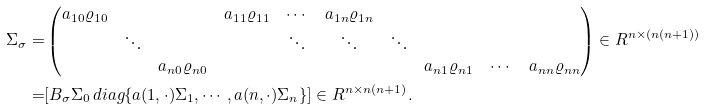<formula> <loc_0><loc_0><loc_500><loc_500>\Sigma _ { \sigma } = & \begin{pmatrix} a _ { 1 0 } \varrho _ { 1 0 } & & & a _ { 1 1 } \varrho _ { 1 1 } & \cdots & a _ { 1 n } \varrho _ { 1 n } & & & & \\ & \ddots & & & \ddots & \ddots & \ddots & & & \\ & & a _ { n 0 } \varrho _ { n 0 } & & & & & a _ { n 1 } \varrho _ { n 1 } & \cdots & a _ { n n } \varrho _ { n n } \end{pmatrix} \in R ^ { n \times ( n ( n + 1 ) ) } \\ = & [ B _ { \sigma } \Sigma _ { 0 } \, d i a g \{ a ( 1 , \cdot ) \Sigma _ { 1 } , \cdots , a ( n , \cdot ) \Sigma _ { n } \} ] \in R ^ { n \times n ( n + 1 ) } .</formula> 